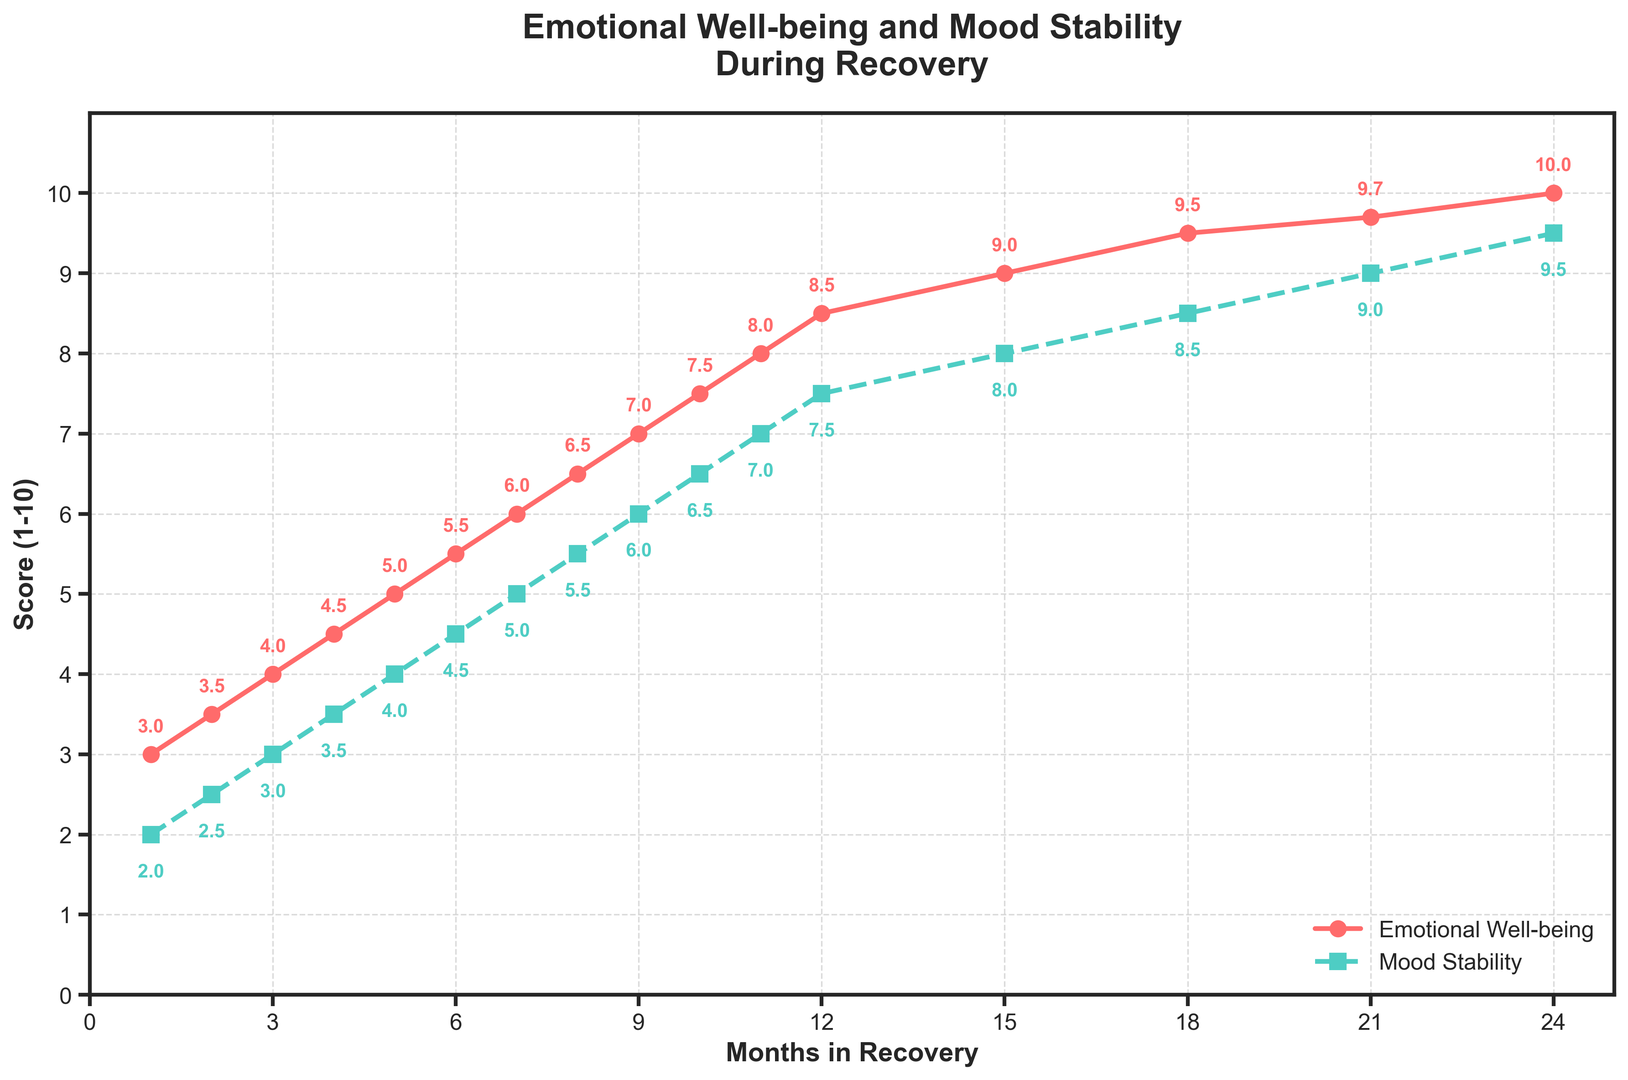What is the emotion well-being score at month 10? Look at the plot and find the point labeled "Emotional Well-being" at month 10. The value corresponding to this point is 7.5.
Answer: 7.5 Which month shows an emotional well-being score of 9? Identify the point labeled "Emotional Well-being" that is at the vertical level 9. Trace horizontally to find the corresponding month; it is month 15.
Answer: 15 How much does mood stability improve from month 1 to month 24? Find the "Mood Stability" scores at months 1 and 24. Subtract the initial score (2) from the final score (9.5): 9.5 - 2 = 7.5.
Answer: 7.5 Which has a higher value at month 12, emotional well-being, or mood stability? Compare the values at month 12 for "Emotional Well-being" and "Mood Stability". Emotional Well-being is 8.5, and Mood Stability is 7.5. Therefore, Emotional Well-being is higher.
Answer: Emotional Well-being What is the average score of emotional well-being at months 1, 6, and 12? Calculate the average by summing the scores at months 1 (3), 6 (5.5), and 12 (8.5), then divide by 3. (3 + 5.5 + 8.5)/3 = 17/3 = 5.67.
Answer: 5.67 Between months 6 and 18, during which month does emotional well-being transition above the midpoint score of 5? Note that the emotional well-being score is precisely 5 at month 5. It moves from 5 to above 5 between month 5 and month 6, indicating the transition occurs at month 6.
Answer: 6 How many months does it take for mood stability to reach a score of 7? Find the "Mood Stability" score of 7 in the plot and trace back horizontally to see that it occurs at month 11.
Answer: 11 Is the emotional well-being score at month 18 closer to its maximum or minimum value during the 24 months? The emotional well-being score at month 18 is 9.5. The minimum value is 3, and the maximum value is 10. Calculate the distance from 9.5 to those values: 9.5 - 3 = 6.5 and 10 - 9.5 = 0.5. It is closer to the maximum.
Answer: Maximum Which data type between emotional well-being and mood stability achieves a score of 5 first? From the plot, emotional well-being reaches 5 at month 5, while mood stability reaches 5 at month 7. So, Emotional well-being achieves it first.
Answer: Emotional well-being What is the overall trend observed for both emotional well-being and mood stability over the 24 months period? By observing both the "Emotional Well-being" and "Mood Stability" lines, it's clear they both show an increasing trend from month 1 to month 24.
Answer: Increasing 